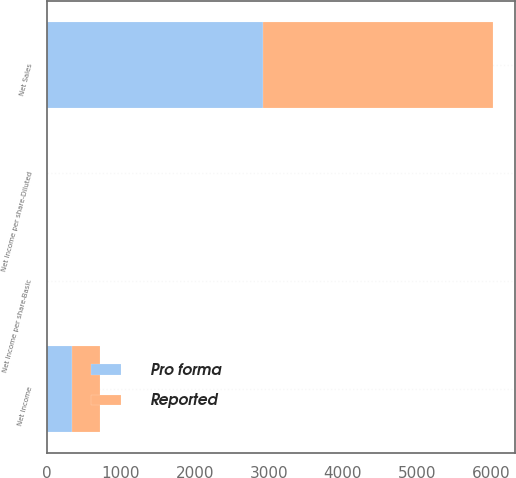Convert chart to OTSL. <chart><loc_0><loc_0><loc_500><loc_500><stacked_bar_chart><ecel><fcel>Net Sales<fcel>Net Income<fcel>Net Income per share-Basic<fcel>Net Income per share-Diluted<nl><fcel>Pro forma<fcel>2921.9<fcel>349.8<fcel>2.5<fcel>2.45<nl><fcel>Reported<fcel>3106<fcel>374.9<fcel>2.68<fcel>2.63<nl></chart> 